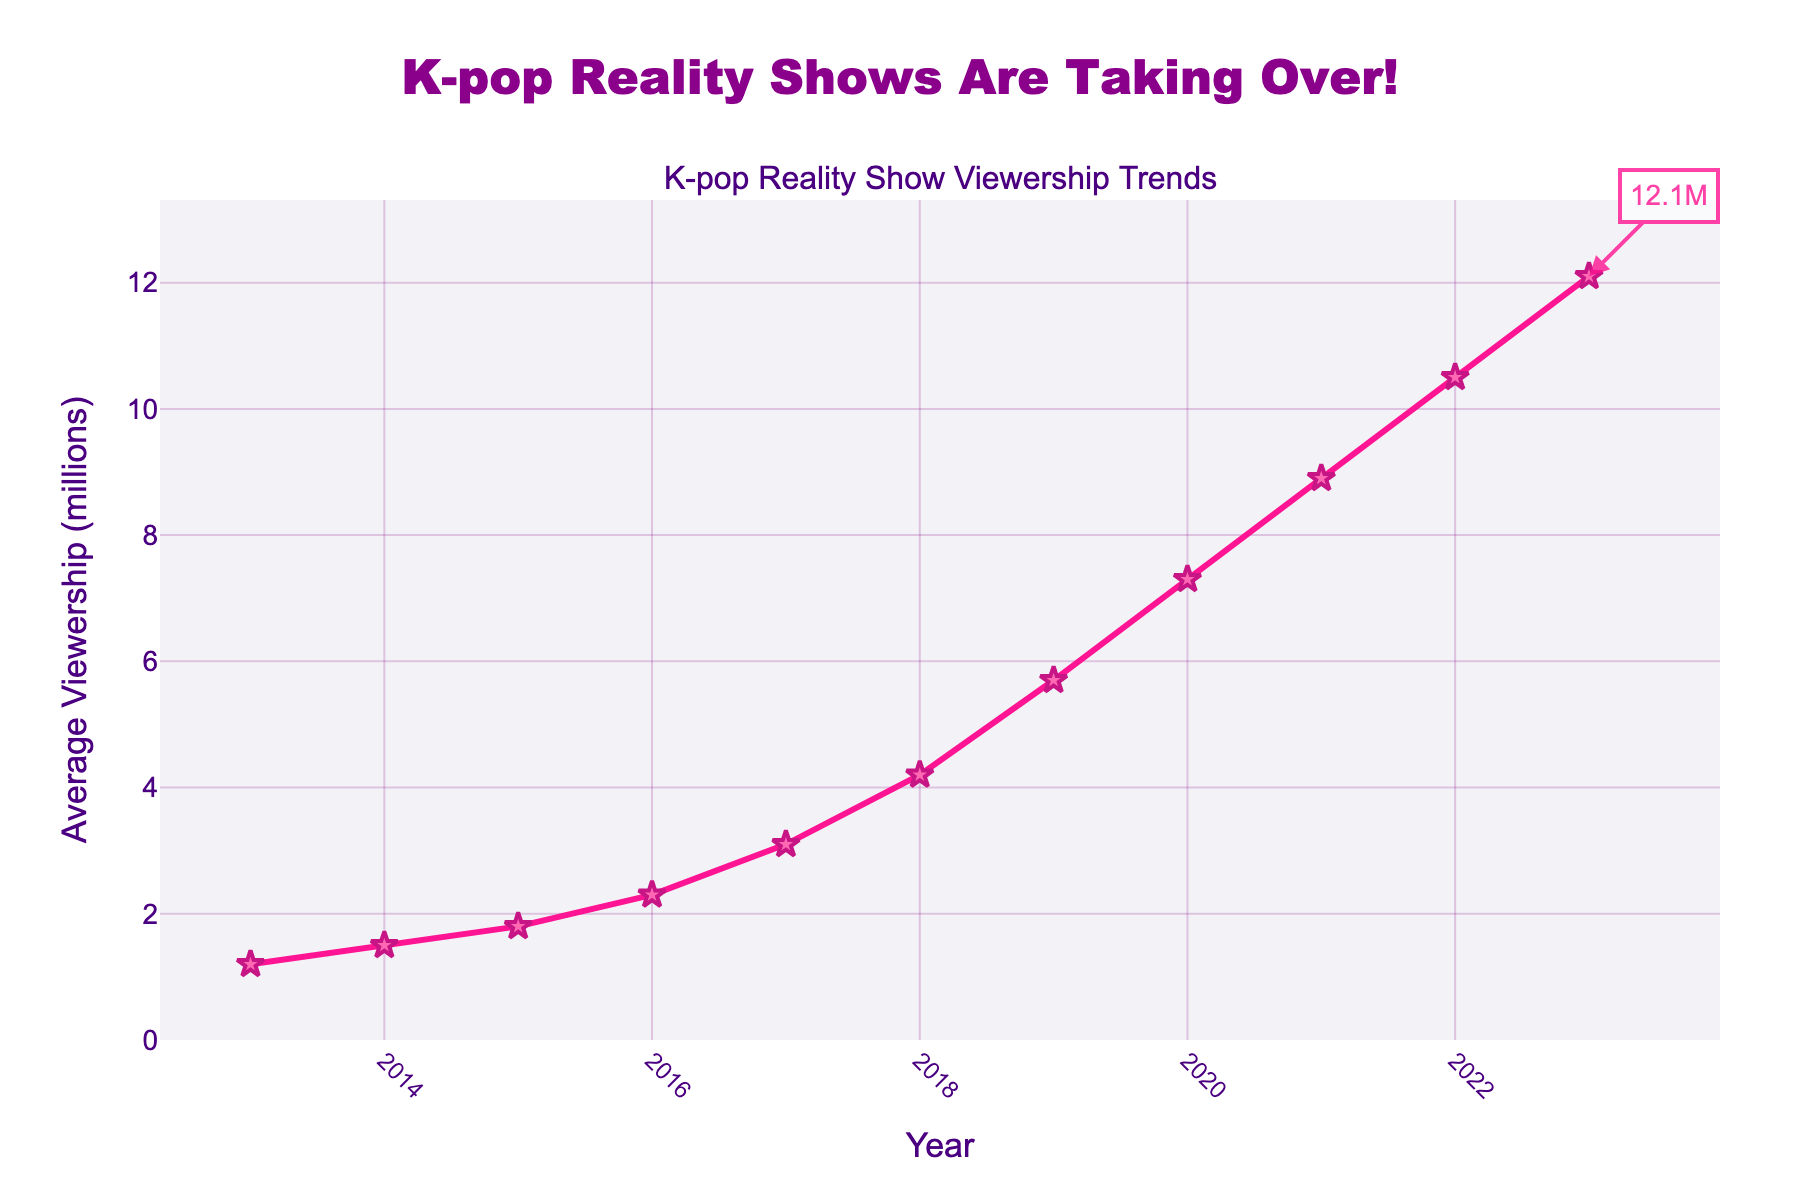What is the average viewership for K-pop reality shows in 2017? To find the average viewership for K-pop reality shows in 2017, simply refer to the data point on the line chart at the year 2017.
Answer: 3.1 million How much did the average viewership increase from 2013 to 2023? The average viewership in 2013 was 1.2 million, and it increased to 12.1 million in 2023. Subtract the 2013 value from the 2023 value: 12.1 million - 1.2 million = 10.9 million.
Answer: 10.9 million Between which years did the average viewership see the greatest increase? Look at the line chart and identify which two consecutive years have the steepest upward slope. The largest increase is from 2021 (8.9 million) to 2022 (10.5 million).
Answer: 2021 to 2022 What was the average annual increase in viewership from 2013 to 2023? To find the average annual increase, first calculate the total increase from 2013 to 2023. Then divide by the number of years: (12.1 million - 1.2 million) / (2023 - 2013) = 10.9 million / 10 = 1.09 million.
Answer: 1.09 million In which year did the viewership first reach over 5 million? Look at the line chart and identify the first year where the data point surpasses 5 million. In 2019, the viewership was 5.7 million.
Answer: 2019 What is the percentage increase in viewership from 2016 to 2017? To find the percentage increase, subtract the 2016 figure from the 2017 figure, then divide by the 2016 figure and multiply by 100: [(3.1 million - 2.3 million) / 2.3 million] * 100 = 34.8%.
Answer: 34.8% What is the midpoint (median) viewership across the decade? List all viewership figures from 2013 to 2023: [1.2, 1.5, 1.8, 2.3, 3.1, 4.2, 5.7, 7.3, 8.9, 10.5, 12.1] and find the middle value. The median is the 6th value: 4.2 million.
Answer: 4.2 million Which year had exactly double the viewership of the year 2015? The viewership in 2015 was 1.8 million. Double this is 3.6 million, which does not exactly match any data point. However, viewership closest to 3.6 million is in 2017 (3.1 million).
Answer: Not exactly double What color is used to mark the highest viewership point on the plot? The highest viewership is marked with a star, which is filled with a shade of pink/purple.
Answer: Pink/Purple Between which years does the chart show the sharpest visual upward trend? Look at the visual steepness of the line on the chart. The sharpest upward trend visually occurs between 2020 and 2022.
Answer: 2020 to 2022 